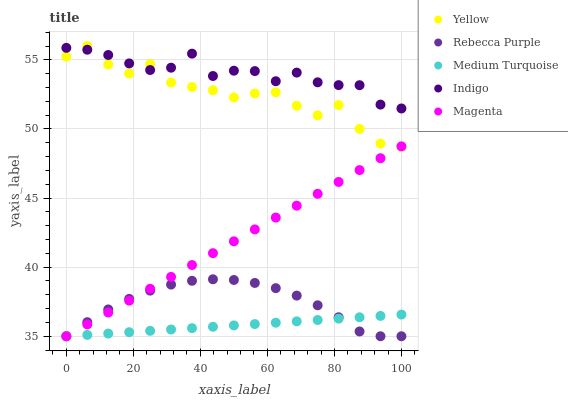Does Medium Turquoise have the minimum area under the curve?
Answer yes or no. Yes. Does Indigo have the maximum area under the curve?
Answer yes or no. Yes. Does Indigo have the minimum area under the curve?
Answer yes or no. No. Does Medium Turquoise have the maximum area under the curve?
Answer yes or no. No. Is Medium Turquoise the smoothest?
Answer yes or no. Yes. Is Yellow the roughest?
Answer yes or no. Yes. Is Indigo the smoothest?
Answer yes or no. No. Is Indigo the roughest?
Answer yes or no. No. Does Magenta have the lowest value?
Answer yes or no. Yes. Does Indigo have the lowest value?
Answer yes or no. No. Does Yellow have the highest value?
Answer yes or no. Yes. Does Indigo have the highest value?
Answer yes or no. No. Is Medium Turquoise less than Yellow?
Answer yes or no. Yes. Is Indigo greater than Rebecca Purple?
Answer yes or no. Yes. Does Indigo intersect Yellow?
Answer yes or no. Yes. Is Indigo less than Yellow?
Answer yes or no. No. Is Indigo greater than Yellow?
Answer yes or no. No. Does Medium Turquoise intersect Yellow?
Answer yes or no. No. 